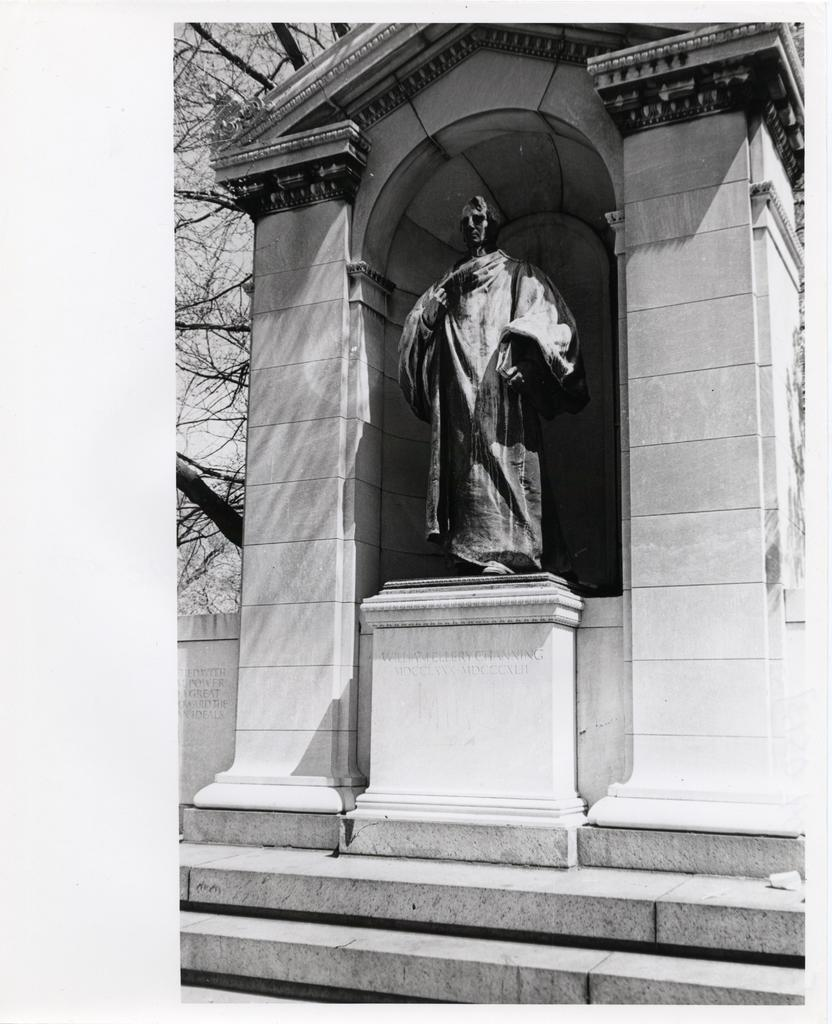What is the color scheme of the image? The image is black and white. What is the main subject in the image? There is a statue in the image. What can be seen in the background of the image? There are trees and the sky visible in the background of the image. What type of wrench is being used by the achiever in the image? There is no achiever or wrench present in the image; it features a statue and a background with trees and the sky. 